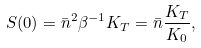<formula> <loc_0><loc_0><loc_500><loc_500>S ( 0 ) = \bar { n } ^ { 2 } \beta ^ { - 1 } K _ { T } = \bar { n } \frac { K _ { T } } { K _ { 0 } } ,</formula> 